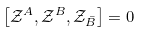<formula> <loc_0><loc_0><loc_500><loc_500>\left [ \mathcal { Z } ^ { A } , \mathcal { Z } ^ { B } , \mathcal { Z } _ { \bar { B } } \right ] = 0 \,</formula> 